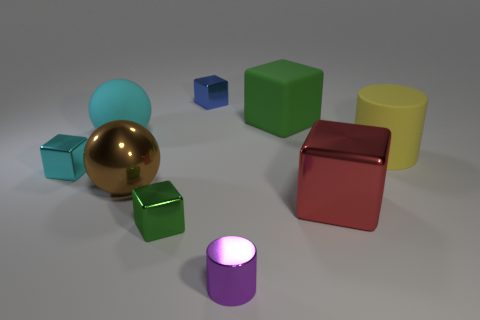Does the big rubber cube have the same color as the big shiny object that is to the left of the big green rubber cube? No, the big rubber cube does not have the same color as the shiny object to the left of the big green rubber cube. The big rubber cube is red, while the shiny object in question is a golden sphere. 